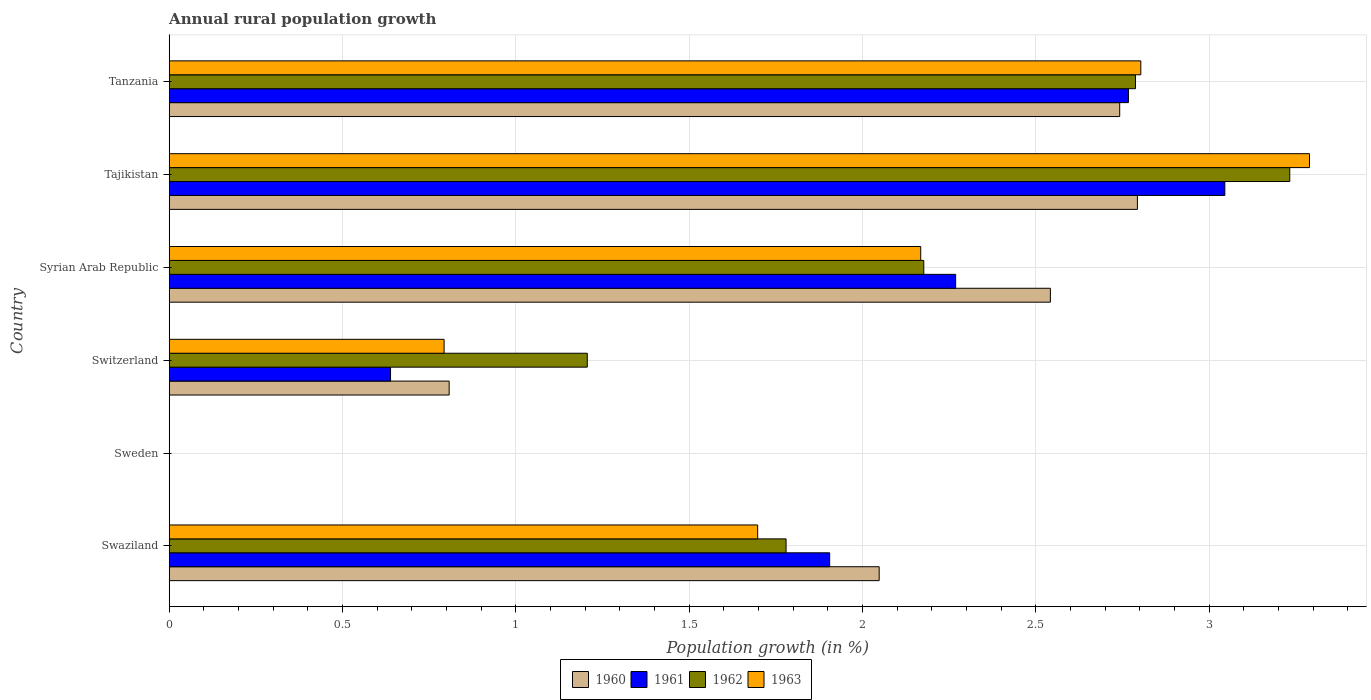How many different coloured bars are there?
Ensure brevity in your answer.  4. Are the number of bars per tick equal to the number of legend labels?
Keep it short and to the point. No. How many bars are there on the 1st tick from the bottom?
Provide a short and direct response. 4. What is the percentage of rural population growth in 1960 in Swaziland?
Offer a very short reply. 2.05. Across all countries, what is the maximum percentage of rural population growth in 1960?
Offer a very short reply. 2.79. Across all countries, what is the minimum percentage of rural population growth in 1962?
Your answer should be very brief. 0. In which country was the percentage of rural population growth in 1960 maximum?
Give a very brief answer. Tajikistan. What is the total percentage of rural population growth in 1961 in the graph?
Make the answer very short. 10.63. What is the difference between the percentage of rural population growth in 1963 in Swaziland and that in Switzerland?
Offer a very short reply. 0.9. What is the difference between the percentage of rural population growth in 1960 in Tanzania and the percentage of rural population growth in 1963 in Sweden?
Give a very brief answer. 2.74. What is the average percentage of rural population growth in 1960 per country?
Make the answer very short. 1.82. What is the difference between the percentage of rural population growth in 1962 and percentage of rural population growth in 1960 in Tanzania?
Keep it short and to the point. 0.05. What is the ratio of the percentage of rural population growth in 1963 in Syrian Arab Republic to that in Tanzania?
Your response must be concise. 0.77. Is the percentage of rural population growth in 1962 in Swaziland less than that in Tajikistan?
Keep it short and to the point. Yes. What is the difference between the highest and the second highest percentage of rural population growth in 1961?
Keep it short and to the point. 0.28. What is the difference between the highest and the lowest percentage of rural population growth in 1962?
Your response must be concise. 3.23. In how many countries, is the percentage of rural population growth in 1960 greater than the average percentage of rural population growth in 1960 taken over all countries?
Make the answer very short. 4. Are the values on the major ticks of X-axis written in scientific E-notation?
Your answer should be very brief. No. Does the graph contain any zero values?
Offer a very short reply. Yes. Does the graph contain grids?
Your response must be concise. Yes. Where does the legend appear in the graph?
Ensure brevity in your answer.  Bottom center. What is the title of the graph?
Provide a short and direct response. Annual rural population growth. What is the label or title of the X-axis?
Give a very brief answer. Population growth (in %). What is the label or title of the Y-axis?
Your answer should be compact. Country. What is the Population growth (in %) of 1960 in Swaziland?
Keep it short and to the point. 2.05. What is the Population growth (in %) of 1961 in Swaziland?
Offer a terse response. 1.91. What is the Population growth (in %) of 1962 in Swaziland?
Ensure brevity in your answer.  1.78. What is the Population growth (in %) of 1963 in Swaziland?
Your answer should be very brief. 1.7. What is the Population growth (in %) in 1961 in Sweden?
Provide a short and direct response. 0. What is the Population growth (in %) of 1963 in Sweden?
Your answer should be very brief. 0. What is the Population growth (in %) in 1960 in Switzerland?
Your response must be concise. 0.81. What is the Population growth (in %) of 1961 in Switzerland?
Your answer should be compact. 0.64. What is the Population growth (in %) of 1962 in Switzerland?
Make the answer very short. 1.21. What is the Population growth (in %) of 1963 in Switzerland?
Make the answer very short. 0.79. What is the Population growth (in %) in 1960 in Syrian Arab Republic?
Make the answer very short. 2.54. What is the Population growth (in %) in 1961 in Syrian Arab Republic?
Offer a very short reply. 2.27. What is the Population growth (in %) in 1962 in Syrian Arab Republic?
Offer a very short reply. 2.18. What is the Population growth (in %) in 1963 in Syrian Arab Republic?
Offer a very short reply. 2.17. What is the Population growth (in %) of 1960 in Tajikistan?
Provide a succinct answer. 2.79. What is the Population growth (in %) in 1961 in Tajikistan?
Your response must be concise. 3.05. What is the Population growth (in %) in 1962 in Tajikistan?
Provide a short and direct response. 3.23. What is the Population growth (in %) of 1963 in Tajikistan?
Ensure brevity in your answer.  3.29. What is the Population growth (in %) in 1960 in Tanzania?
Your response must be concise. 2.74. What is the Population growth (in %) of 1961 in Tanzania?
Provide a succinct answer. 2.77. What is the Population growth (in %) in 1962 in Tanzania?
Give a very brief answer. 2.79. What is the Population growth (in %) of 1963 in Tanzania?
Ensure brevity in your answer.  2.8. Across all countries, what is the maximum Population growth (in %) in 1960?
Keep it short and to the point. 2.79. Across all countries, what is the maximum Population growth (in %) in 1961?
Your response must be concise. 3.05. Across all countries, what is the maximum Population growth (in %) in 1962?
Provide a short and direct response. 3.23. Across all countries, what is the maximum Population growth (in %) in 1963?
Give a very brief answer. 3.29. Across all countries, what is the minimum Population growth (in %) of 1960?
Provide a succinct answer. 0. Across all countries, what is the minimum Population growth (in %) in 1963?
Your answer should be compact. 0. What is the total Population growth (in %) in 1960 in the graph?
Give a very brief answer. 10.93. What is the total Population growth (in %) in 1961 in the graph?
Keep it short and to the point. 10.63. What is the total Population growth (in %) of 1962 in the graph?
Your answer should be very brief. 11.18. What is the total Population growth (in %) in 1963 in the graph?
Provide a short and direct response. 10.75. What is the difference between the Population growth (in %) of 1960 in Swaziland and that in Switzerland?
Offer a very short reply. 1.24. What is the difference between the Population growth (in %) of 1961 in Swaziland and that in Switzerland?
Your answer should be compact. 1.27. What is the difference between the Population growth (in %) in 1962 in Swaziland and that in Switzerland?
Offer a terse response. 0.57. What is the difference between the Population growth (in %) in 1963 in Swaziland and that in Switzerland?
Ensure brevity in your answer.  0.9. What is the difference between the Population growth (in %) of 1960 in Swaziland and that in Syrian Arab Republic?
Give a very brief answer. -0.49. What is the difference between the Population growth (in %) in 1961 in Swaziland and that in Syrian Arab Republic?
Keep it short and to the point. -0.36. What is the difference between the Population growth (in %) in 1962 in Swaziland and that in Syrian Arab Republic?
Ensure brevity in your answer.  -0.4. What is the difference between the Population growth (in %) in 1963 in Swaziland and that in Syrian Arab Republic?
Provide a short and direct response. -0.47. What is the difference between the Population growth (in %) in 1960 in Swaziland and that in Tajikistan?
Your answer should be very brief. -0.74. What is the difference between the Population growth (in %) of 1961 in Swaziland and that in Tajikistan?
Keep it short and to the point. -1.14. What is the difference between the Population growth (in %) in 1962 in Swaziland and that in Tajikistan?
Provide a short and direct response. -1.45. What is the difference between the Population growth (in %) in 1963 in Swaziland and that in Tajikistan?
Make the answer very short. -1.59. What is the difference between the Population growth (in %) in 1960 in Swaziland and that in Tanzania?
Provide a succinct answer. -0.69. What is the difference between the Population growth (in %) in 1961 in Swaziland and that in Tanzania?
Make the answer very short. -0.86. What is the difference between the Population growth (in %) of 1962 in Swaziland and that in Tanzania?
Make the answer very short. -1.01. What is the difference between the Population growth (in %) in 1963 in Swaziland and that in Tanzania?
Your answer should be compact. -1.11. What is the difference between the Population growth (in %) in 1960 in Switzerland and that in Syrian Arab Republic?
Make the answer very short. -1.73. What is the difference between the Population growth (in %) of 1961 in Switzerland and that in Syrian Arab Republic?
Your answer should be very brief. -1.63. What is the difference between the Population growth (in %) in 1962 in Switzerland and that in Syrian Arab Republic?
Offer a terse response. -0.97. What is the difference between the Population growth (in %) of 1963 in Switzerland and that in Syrian Arab Republic?
Your response must be concise. -1.38. What is the difference between the Population growth (in %) in 1960 in Switzerland and that in Tajikistan?
Ensure brevity in your answer.  -1.99. What is the difference between the Population growth (in %) of 1961 in Switzerland and that in Tajikistan?
Give a very brief answer. -2.41. What is the difference between the Population growth (in %) of 1962 in Switzerland and that in Tajikistan?
Your answer should be compact. -2.03. What is the difference between the Population growth (in %) of 1963 in Switzerland and that in Tajikistan?
Your response must be concise. -2.5. What is the difference between the Population growth (in %) in 1960 in Switzerland and that in Tanzania?
Offer a very short reply. -1.93. What is the difference between the Population growth (in %) in 1961 in Switzerland and that in Tanzania?
Keep it short and to the point. -2.13. What is the difference between the Population growth (in %) of 1962 in Switzerland and that in Tanzania?
Provide a succinct answer. -1.58. What is the difference between the Population growth (in %) of 1963 in Switzerland and that in Tanzania?
Ensure brevity in your answer.  -2.01. What is the difference between the Population growth (in %) of 1960 in Syrian Arab Republic and that in Tajikistan?
Keep it short and to the point. -0.25. What is the difference between the Population growth (in %) in 1961 in Syrian Arab Republic and that in Tajikistan?
Give a very brief answer. -0.78. What is the difference between the Population growth (in %) in 1962 in Syrian Arab Republic and that in Tajikistan?
Provide a short and direct response. -1.06. What is the difference between the Population growth (in %) in 1963 in Syrian Arab Republic and that in Tajikistan?
Offer a terse response. -1.12. What is the difference between the Population growth (in %) in 1960 in Syrian Arab Republic and that in Tanzania?
Offer a very short reply. -0.2. What is the difference between the Population growth (in %) in 1961 in Syrian Arab Republic and that in Tanzania?
Your answer should be very brief. -0.5. What is the difference between the Population growth (in %) of 1962 in Syrian Arab Republic and that in Tanzania?
Provide a succinct answer. -0.61. What is the difference between the Population growth (in %) of 1963 in Syrian Arab Republic and that in Tanzania?
Keep it short and to the point. -0.64. What is the difference between the Population growth (in %) in 1960 in Tajikistan and that in Tanzania?
Your answer should be compact. 0.05. What is the difference between the Population growth (in %) in 1961 in Tajikistan and that in Tanzania?
Provide a short and direct response. 0.28. What is the difference between the Population growth (in %) in 1962 in Tajikistan and that in Tanzania?
Provide a short and direct response. 0.45. What is the difference between the Population growth (in %) of 1963 in Tajikistan and that in Tanzania?
Your answer should be compact. 0.49. What is the difference between the Population growth (in %) of 1960 in Swaziland and the Population growth (in %) of 1961 in Switzerland?
Keep it short and to the point. 1.41. What is the difference between the Population growth (in %) of 1960 in Swaziland and the Population growth (in %) of 1962 in Switzerland?
Offer a very short reply. 0.84. What is the difference between the Population growth (in %) of 1960 in Swaziland and the Population growth (in %) of 1963 in Switzerland?
Your answer should be compact. 1.26. What is the difference between the Population growth (in %) in 1961 in Swaziland and the Population growth (in %) in 1962 in Switzerland?
Offer a terse response. 0.7. What is the difference between the Population growth (in %) in 1961 in Swaziland and the Population growth (in %) in 1963 in Switzerland?
Give a very brief answer. 1.11. What is the difference between the Population growth (in %) in 1962 in Swaziland and the Population growth (in %) in 1963 in Switzerland?
Provide a short and direct response. 0.99. What is the difference between the Population growth (in %) in 1960 in Swaziland and the Population growth (in %) in 1961 in Syrian Arab Republic?
Provide a succinct answer. -0.22. What is the difference between the Population growth (in %) in 1960 in Swaziland and the Population growth (in %) in 1962 in Syrian Arab Republic?
Provide a short and direct response. -0.13. What is the difference between the Population growth (in %) in 1960 in Swaziland and the Population growth (in %) in 1963 in Syrian Arab Republic?
Your answer should be very brief. -0.12. What is the difference between the Population growth (in %) in 1961 in Swaziland and the Population growth (in %) in 1962 in Syrian Arab Republic?
Ensure brevity in your answer.  -0.27. What is the difference between the Population growth (in %) in 1961 in Swaziland and the Population growth (in %) in 1963 in Syrian Arab Republic?
Provide a short and direct response. -0.26. What is the difference between the Population growth (in %) in 1962 in Swaziland and the Population growth (in %) in 1963 in Syrian Arab Republic?
Provide a succinct answer. -0.39. What is the difference between the Population growth (in %) in 1960 in Swaziland and the Population growth (in %) in 1961 in Tajikistan?
Offer a very short reply. -1. What is the difference between the Population growth (in %) in 1960 in Swaziland and the Population growth (in %) in 1962 in Tajikistan?
Ensure brevity in your answer.  -1.18. What is the difference between the Population growth (in %) in 1960 in Swaziland and the Population growth (in %) in 1963 in Tajikistan?
Your answer should be compact. -1.24. What is the difference between the Population growth (in %) of 1961 in Swaziland and the Population growth (in %) of 1962 in Tajikistan?
Make the answer very short. -1.33. What is the difference between the Population growth (in %) in 1961 in Swaziland and the Population growth (in %) in 1963 in Tajikistan?
Keep it short and to the point. -1.38. What is the difference between the Population growth (in %) of 1962 in Swaziland and the Population growth (in %) of 1963 in Tajikistan?
Your response must be concise. -1.51. What is the difference between the Population growth (in %) in 1960 in Swaziland and the Population growth (in %) in 1961 in Tanzania?
Make the answer very short. -0.72. What is the difference between the Population growth (in %) in 1960 in Swaziland and the Population growth (in %) in 1962 in Tanzania?
Provide a short and direct response. -0.74. What is the difference between the Population growth (in %) in 1960 in Swaziland and the Population growth (in %) in 1963 in Tanzania?
Your response must be concise. -0.75. What is the difference between the Population growth (in %) of 1961 in Swaziland and the Population growth (in %) of 1962 in Tanzania?
Keep it short and to the point. -0.88. What is the difference between the Population growth (in %) in 1961 in Swaziland and the Population growth (in %) in 1963 in Tanzania?
Give a very brief answer. -0.9. What is the difference between the Population growth (in %) of 1962 in Swaziland and the Population growth (in %) of 1963 in Tanzania?
Make the answer very short. -1.02. What is the difference between the Population growth (in %) of 1960 in Switzerland and the Population growth (in %) of 1961 in Syrian Arab Republic?
Your answer should be compact. -1.46. What is the difference between the Population growth (in %) of 1960 in Switzerland and the Population growth (in %) of 1962 in Syrian Arab Republic?
Your answer should be compact. -1.37. What is the difference between the Population growth (in %) in 1960 in Switzerland and the Population growth (in %) in 1963 in Syrian Arab Republic?
Your answer should be compact. -1.36. What is the difference between the Population growth (in %) in 1961 in Switzerland and the Population growth (in %) in 1962 in Syrian Arab Republic?
Your response must be concise. -1.54. What is the difference between the Population growth (in %) of 1961 in Switzerland and the Population growth (in %) of 1963 in Syrian Arab Republic?
Offer a very short reply. -1.53. What is the difference between the Population growth (in %) in 1962 in Switzerland and the Population growth (in %) in 1963 in Syrian Arab Republic?
Provide a succinct answer. -0.96. What is the difference between the Population growth (in %) of 1960 in Switzerland and the Population growth (in %) of 1961 in Tajikistan?
Make the answer very short. -2.24. What is the difference between the Population growth (in %) of 1960 in Switzerland and the Population growth (in %) of 1962 in Tajikistan?
Provide a short and direct response. -2.42. What is the difference between the Population growth (in %) in 1960 in Switzerland and the Population growth (in %) in 1963 in Tajikistan?
Give a very brief answer. -2.48. What is the difference between the Population growth (in %) of 1961 in Switzerland and the Population growth (in %) of 1962 in Tajikistan?
Offer a very short reply. -2.59. What is the difference between the Population growth (in %) in 1961 in Switzerland and the Population growth (in %) in 1963 in Tajikistan?
Your answer should be compact. -2.65. What is the difference between the Population growth (in %) in 1962 in Switzerland and the Population growth (in %) in 1963 in Tajikistan?
Give a very brief answer. -2.08. What is the difference between the Population growth (in %) of 1960 in Switzerland and the Population growth (in %) of 1961 in Tanzania?
Your response must be concise. -1.96. What is the difference between the Population growth (in %) of 1960 in Switzerland and the Population growth (in %) of 1962 in Tanzania?
Your answer should be very brief. -1.98. What is the difference between the Population growth (in %) of 1960 in Switzerland and the Population growth (in %) of 1963 in Tanzania?
Provide a short and direct response. -2. What is the difference between the Population growth (in %) in 1961 in Switzerland and the Population growth (in %) in 1962 in Tanzania?
Provide a short and direct response. -2.15. What is the difference between the Population growth (in %) of 1961 in Switzerland and the Population growth (in %) of 1963 in Tanzania?
Offer a terse response. -2.16. What is the difference between the Population growth (in %) in 1962 in Switzerland and the Population growth (in %) in 1963 in Tanzania?
Make the answer very short. -1.6. What is the difference between the Population growth (in %) in 1960 in Syrian Arab Republic and the Population growth (in %) in 1961 in Tajikistan?
Provide a short and direct response. -0.5. What is the difference between the Population growth (in %) of 1960 in Syrian Arab Republic and the Population growth (in %) of 1962 in Tajikistan?
Ensure brevity in your answer.  -0.69. What is the difference between the Population growth (in %) in 1960 in Syrian Arab Republic and the Population growth (in %) in 1963 in Tajikistan?
Make the answer very short. -0.75. What is the difference between the Population growth (in %) of 1961 in Syrian Arab Republic and the Population growth (in %) of 1962 in Tajikistan?
Your response must be concise. -0.96. What is the difference between the Population growth (in %) of 1961 in Syrian Arab Republic and the Population growth (in %) of 1963 in Tajikistan?
Offer a terse response. -1.02. What is the difference between the Population growth (in %) of 1962 in Syrian Arab Republic and the Population growth (in %) of 1963 in Tajikistan?
Offer a terse response. -1.11. What is the difference between the Population growth (in %) in 1960 in Syrian Arab Republic and the Population growth (in %) in 1961 in Tanzania?
Give a very brief answer. -0.23. What is the difference between the Population growth (in %) of 1960 in Syrian Arab Republic and the Population growth (in %) of 1962 in Tanzania?
Your answer should be compact. -0.25. What is the difference between the Population growth (in %) in 1960 in Syrian Arab Republic and the Population growth (in %) in 1963 in Tanzania?
Provide a succinct answer. -0.26. What is the difference between the Population growth (in %) of 1961 in Syrian Arab Republic and the Population growth (in %) of 1962 in Tanzania?
Your answer should be very brief. -0.52. What is the difference between the Population growth (in %) in 1961 in Syrian Arab Republic and the Population growth (in %) in 1963 in Tanzania?
Make the answer very short. -0.53. What is the difference between the Population growth (in %) of 1962 in Syrian Arab Republic and the Population growth (in %) of 1963 in Tanzania?
Give a very brief answer. -0.63. What is the difference between the Population growth (in %) in 1960 in Tajikistan and the Population growth (in %) in 1961 in Tanzania?
Provide a succinct answer. 0.03. What is the difference between the Population growth (in %) of 1960 in Tajikistan and the Population growth (in %) of 1962 in Tanzania?
Make the answer very short. 0.01. What is the difference between the Population growth (in %) in 1960 in Tajikistan and the Population growth (in %) in 1963 in Tanzania?
Offer a very short reply. -0.01. What is the difference between the Population growth (in %) of 1961 in Tajikistan and the Population growth (in %) of 1962 in Tanzania?
Your answer should be compact. 0.26. What is the difference between the Population growth (in %) of 1961 in Tajikistan and the Population growth (in %) of 1963 in Tanzania?
Give a very brief answer. 0.24. What is the difference between the Population growth (in %) in 1962 in Tajikistan and the Population growth (in %) in 1963 in Tanzania?
Your response must be concise. 0.43. What is the average Population growth (in %) in 1960 per country?
Keep it short and to the point. 1.82. What is the average Population growth (in %) of 1961 per country?
Provide a short and direct response. 1.77. What is the average Population growth (in %) of 1962 per country?
Make the answer very short. 1.86. What is the average Population growth (in %) of 1963 per country?
Offer a terse response. 1.79. What is the difference between the Population growth (in %) in 1960 and Population growth (in %) in 1961 in Swaziland?
Make the answer very short. 0.14. What is the difference between the Population growth (in %) in 1960 and Population growth (in %) in 1962 in Swaziland?
Offer a terse response. 0.27. What is the difference between the Population growth (in %) in 1960 and Population growth (in %) in 1963 in Swaziland?
Provide a short and direct response. 0.35. What is the difference between the Population growth (in %) of 1961 and Population growth (in %) of 1962 in Swaziland?
Offer a terse response. 0.13. What is the difference between the Population growth (in %) in 1961 and Population growth (in %) in 1963 in Swaziland?
Keep it short and to the point. 0.21. What is the difference between the Population growth (in %) in 1962 and Population growth (in %) in 1963 in Swaziland?
Provide a short and direct response. 0.08. What is the difference between the Population growth (in %) in 1960 and Population growth (in %) in 1961 in Switzerland?
Give a very brief answer. 0.17. What is the difference between the Population growth (in %) in 1960 and Population growth (in %) in 1962 in Switzerland?
Your answer should be compact. -0.4. What is the difference between the Population growth (in %) in 1960 and Population growth (in %) in 1963 in Switzerland?
Your answer should be very brief. 0.01. What is the difference between the Population growth (in %) in 1961 and Population growth (in %) in 1962 in Switzerland?
Keep it short and to the point. -0.57. What is the difference between the Population growth (in %) in 1961 and Population growth (in %) in 1963 in Switzerland?
Your response must be concise. -0.15. What is the difference between the Population growth (in %) of 1962 and Population growth (in %) of 1963 in Switzerland?
Your answer should be very brief. 0.41. What is the difference between the Population growth (in %) of 1960 and Population growth (in %) of 1961 in Syrian Arab Republic?
Your answer should be very brief. 0.27. What is the difference between the Population growth (in %) of 1960 and Population growth (in %) of 1962 in Syrian Arab Republic?
Your answer should be very brief. 0.37. What is the difference between the Population growth (in %) of 1960 and Population growth (in %) of 1963 in Syrian Arab Republic?
Your response must be concise. 0.37. What is the difference between the Population growth (in %) in 1961 and Population growth (in %) in 1962 in Syrian Arab Republic?
Your response must be concise. 0.09. What is the difference between the Population growth (in %) in 1961 and Population growth (in %) in 1963 in Syrian Arab Republic?
Your answer should be compact. 0.1. What is the difference between the Population growth (in %) in 1962 and Population growth (in %) in 1963 in Syrian Arab Republic?
Offer a very short reply. 0.01. What is the difference between the Population growth (in %) of 1960 and Population growth (in %) of 1961 in Tajikistan?
Offer a terse response. -0.25. What is the difference between the Population growth (in %) of 1960 and Population growth (in %) of 1962 in Tajikistan?
Give a very brief answer. -0.44. What is the difference between the Population growth (in %) of 1960 and Population growth (in %) of 1963 in Tajikistan?
Your response must be concise. -0.5. What is the difference between the Population growth (in %) of 1961 and Population growth (in %) of 1962 in Tajikistan?
Offer a terse response. -0.19. What is the difference between the Population growth (in %) of 1961 and Population growth (in %) of 1963 in Tajikistan?
Your answer should be compact. -0.24. What is the difference between the Population growth (in %) in 1962 and Population growth (in %) in 1963 in Tajikistan?
Your answer should be compact. -0.06. What is the difference between the Population growth (in %) in 1960 and Population growth (in %) in 1961 in Tanzania?
Offer a terse response. -0.03. What is the difference between the Population growth (in %) in 1960 and Population growth (in %) in 1962 in Tanzania?
Ensure brevity in your answer.  -0.05. What is the difference between the Population growth (in %) in 1960 and Population growth (in %) in 1963 in Tanzania?
Make the answer very short. -0.06. What is the difference between the Population growth (in %) of 1961 and Population growth (in %) of 1962 in Tanzania?
Your response must be concise. -0.02. What is the difference between the Population growth (in %) of 1961 and Population growth (in %) of 1963 in Tanzania?
Provide a short and direct response. -0.04. What is the difference between the Population growth (in %) of 1962 and Population growth (in %) of 1963 in Tanzania?
Offer a very short reply. -0.02. What is the ratio of the Population growth (in %) of 1960 in Swaziland to that in Switzerland?
Your answer should be compact. 2.54. What is the ratio of the Population growth (in %) in 1961 in Swaziland to that in Switzerland?
Give a very brief answer. 2.98. What is the ratio of the Population growth (in %) in 1962 in Swaziland to that in Switzerland?
Offer a terse response. 1.48. What is the ratio of the Population growth (in %) of 1963 in Swaziland to that in Switzerland?
Offer a very short reply. 2.14. What is the ratio of the Population growth (in %) of 1960 in Swaziland to that in Syrian Arab Republic?
Make the answer very short. 0.81. What is the ratio of the Population growth (in %) in 1961 in Swaziland to that in Syrian Arab Republic?
Your response must be concise. 0.84. What is the ratio of the Population growth (in %) of 1962 in Swaziland to that in Syrian Arab Republic?
Your answer should be very brief. 0.82. What is the ratio of the Population growth (in %) in 1963 in Swaziland to that in Syrian Arab Republic?
Your response must be concise. 0.78. What is the ratio of the Population growth (in %) of 1960 in Swaziland to that in Tajikistan?
Ensure brevity in your answer.  0.73. What is the ratio of the Population growth (in %) of 1961 in Swaziland to that in Tajikistan?
Your response must be concise. 0.63. What is the ratio of the Population growth (in %) of 1962 in Swaziland to that in Tajikistan?
Keep it short and to the point. 0.55. What is the ratio of the Population growth (in %) of 1963 in Swaziland to that in Tajikistan?
Ensure brevity in your answer.  0.52. What is the ratio of the Population growth (in %) in 1960 in Swaziland to that in Tanzania?
Offer a very short reply. 0.75. What is the ratio of the Population growth (in %) of 1961 in Swaziland to that in Tanzania?
Make the answer very short. 0.69. What is the ratio of the Population growth (in %) of 1962 in Swaziland to that in Tanzania?
Give a very brief answer. 0.64. What is the ratio of the Population growth (in %) of 1963 in Swaziland to that in Tanzania?
Offer a terse response. 0.61. What is the ratio of the Population growth (in %) in 1960 in Switzerland to that in Syrian Arab Republic?
Keep it short and to the point. 0.32. What is the ratio of the Population growth (in %) in 1961 in Switzerland to that in Syrian Arab Republic?
Offer a terse response. 0.28. What is the ratio of the Population growth (in %) of 1962 in Switzerland to that in Syrian Arab Republic?
Keep it short and to the point. 0.55. What is the ratio of the Population growth (in %) of 1963 in Switzerland to that in Syrian Arab Republic?
Provide a short and direct response. 0.37. What is the ratio of the Population growth (in %) in 1960 in Switzerland to that in Tajikistan?
Ensure brevity in your answer.  0.29. What is the ratio of the Population growth (in %) of 1961 in Switzerland to that in Tajikistan?
Your answer should be very brief. 0.21. What is the ratio of the Population growth (in %) in 1962 in Switzerland to that in Tajikistan?
Give a very brief answer. 0.37. What is the ratio of the Population growth (in %) in 1963 in Switzerland to that in Tajikistan?
Provide a short and direct response. 0.24. What is the ratio of the Population growth (in %) of 1960 in Switzerland to that in Tanzania?
Provide a succinct answer. 0.29. What is the ratio of the Population growth (in %) of 1961 in Switzerland to that in Tanzania?
Give a very brief answer. 0.23. What is the ratio of the Population growth (in %) of 1962 in Switzerland to that in Tanzania?
Provide a short and direct response. 0.43. What is the ratio of the Population growth (in %) of 1963 in Switzerland to that in Tanzania?
Your answer should be very brief. 0.28. What is the ratio of the Population growth (in %) in 1960 in Syrian Arab Republic to that in Tajikistan?
Offer a terse response. 0.91. What is the ratio of the Population growth (in %) in 1961 in Syrian Arab Republic to that in Tajikistan?
Your response must be concise. 0.74. What is the ratio of the Population growth (in %) in 1962 in Syrian Arab Republic to that in Tajikistan?
Your answer should be very brief. 0.67. What is the ratio of the Population growth (in %) in 1963 in Syrian Arab Republic to that in Tajikistan?
Provide a short and direct response. 0.66. What is the ratio of the Population growth (in %) in 1960 in Syrian Arab Republic to that in Tanzania?
Make the answer very short. 0.93. What is the ratio of the Population growth (in %) of 1961 in Syrian Arab Republic to that in Tanzania?
Offer a terse response. 0.82. What is the ratio of the Population growth (in %) of 1962 in Syrian Arab Republic to that in Tanzania?
Your response must be concise. 0.78. What is the ratio of the Population growth (in %) in 1963 in Syrian Arab Republic to that in Tanzania?
Ensure brevity in your answer.  0.77. What is the ratio of the Population growth (in %) of 1960 in Tajikistan to that in Tanzania?
Your answer should be compact. 1.02. What is the ratio of the Population growth (in %) in 1961 in Tajikistan to that in Tanzania?
Your response must be concise. 1.1. What is the ratio of the Population growth (in %) of 1962 in Tajikistan to that in Tanzania?
Your response must be concise. 1.16. What is the ratio of the Population growth (in %) of 1963 in Tajikistan to that in Tanzania?
Ensure brevity in your answer.  1.17. What is the difference between the highest and the second highest Population growth (in %) in 1960?
Keep it short and to the point. 0.05. What is the difference between the highest and the second highest Population growth (in %) of 1961?
Keep it short and to the point. 0.28. What is the difference between the highest and the second highest Population growth (in %) in 1962?
Offer a very short reply. 0.45. What is the difference between the highest and the second highest Population growth (in %) of 1963?
Provide a short and direct response. 0.49. What is the difference between the highest and the lowest Population growth (in %) of 1960?
Offer a very short reply. 2.79. What is the difference between the highest and the lowest Population growth (in %) in 1961?
Offer a very short reply. 3.05. What is the difference between the highest and the lowest Population growth (in %) in 1962?
Your response must be concise. 3.23. What is the difference between the highest and the lowest Population growth (in %) in 1963?
Provide a short and direct response. 3.29. 